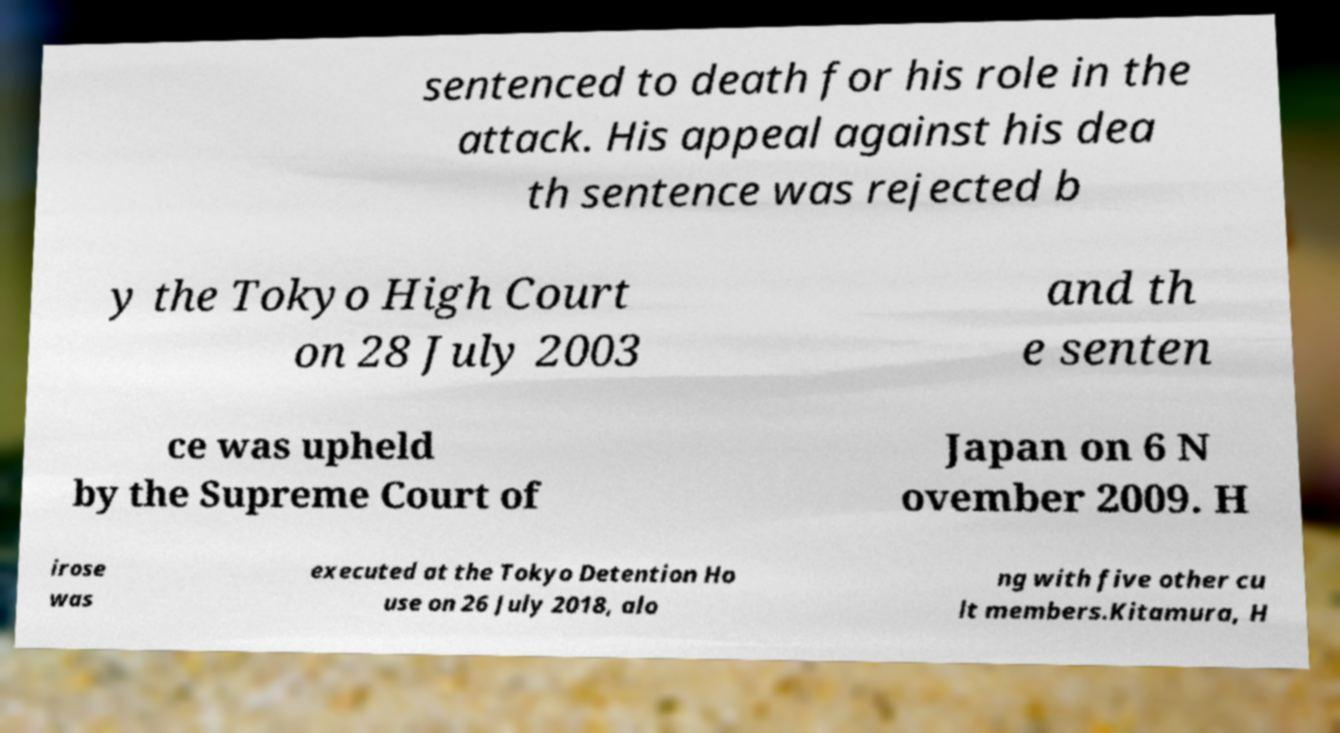I need the written content from this picture converted into text. Can you do that? sentenced to death for his role in the attack. His appeal against his dea th sentence was rejected b y the Tokyo High Court on 28 July 2003 and th e senten ce was upheld by the Supreme Court of Japan on 6 N ovember 2009. H irose was executed at the Tokyo Detention Ho use on 26 July 2018, alo ng with five other cu lt members.Kitamura, H 